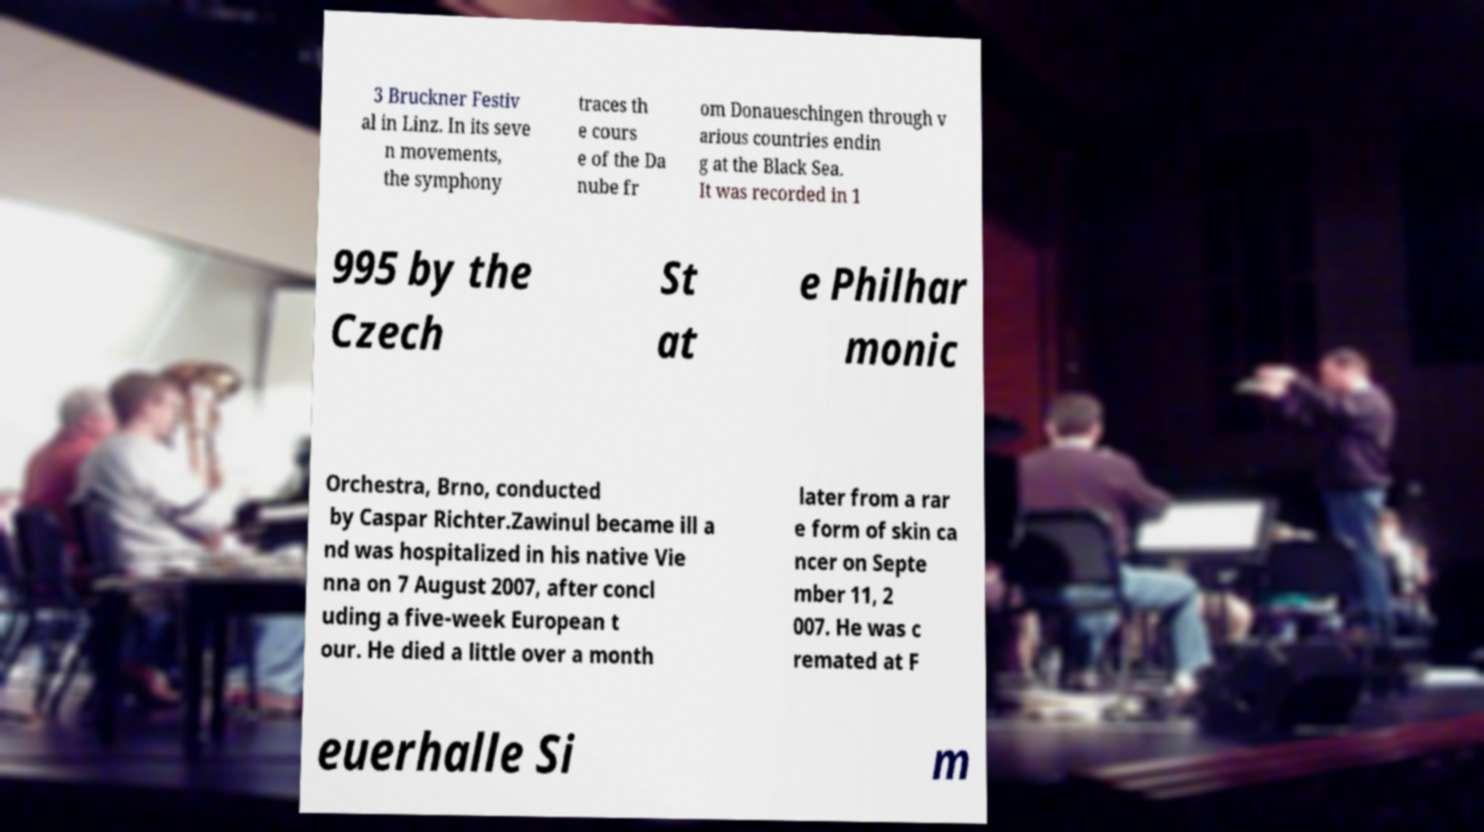Could you assist in decoding the text presented in this image and type it out clearly? 3 Bruckner Festiv al in Linz. In its seve n movements, the symphony traces th e cours e of the Da nube fr om Donaueschingen through v arious countries endin g at the Black Sea. It was recorded in 1 995 by the Czech St at e Philhar monic Orchestra, Brno, conducted by Caspar Richter.Zawinul became ill a nd was hospitalized in his native Vie nna on 7 August 2007, after concl uding a five-week European t our. He died a little over a month later from a rar e form of skin ca ncer on Septe mber 11, 2 007. He was c remated at F euerhalle Si m 